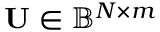Convert formula to latex. <formula><loc_0><loc_0><loc_500><loc_500>U \in \mathbb { B } ^ { N \times m }</formula> 